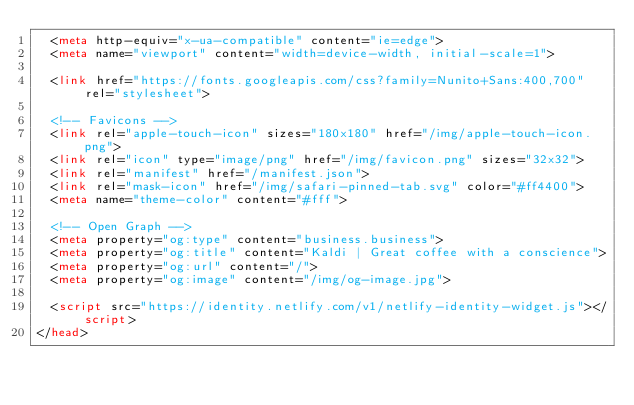<code> <loc_0><loc_0><loc_500><loc_500><_HTML_>	<meta http-equiv="x-ua-compatible" content="ie=edge">
	<meta name="viewport" content="width=device-width, initial-scale=1">

	<link href="https://fonts.googleapis.com/css?family=Nunito+Sans:400,700" rel="stylesheet">

	<!-- Favicons -->
	<link rel="apple-touch-icon" sizes="180x180" href="/img/apple-touch-icon.png">
	<link rel="icon" type="image/png" href="/img/favicon.png" sizes="32x32">
	<link rel="manifest" href="/manifest.json">
	<link rel="mask-icon" href="/img/safari-pinned-tab.svg" color="#ff4400">
	<meta name="theme-color" content="#fff">

	<!-- Open Graph -->
	<meta property="og:type" content="business.business">
	<meta property="og:title" content="Kaldi | Great coffee with a conscience">
	<meta property="og:url" content="/">
	<meta property="og:image" content="/img/og-image.jpg">

	<script src="https://identity.netlify.com/v1/netlify-identity-widget.js"></script>
</head>
</code> 